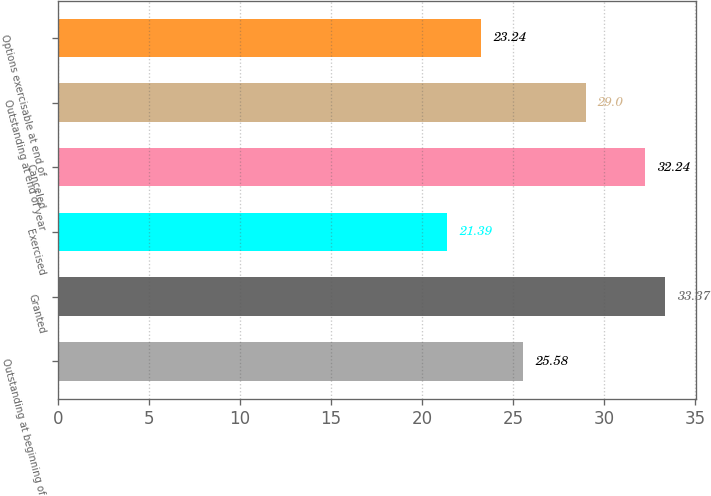Convert chart to OTSL. <chart><loc_0><loc_0><loc_500><loc_500><bar_chart><fcel>Outstanding at beginning of<fcel>Granted<fcel>Exercised<fcel>Canceled<fcel>Outstanding at end of year<fcel>Options exercisable at end of<nl><fcel>25.58<fcel>33.37<fcel>21.39<fcel>32.24<fcel>29<fcel>23.24<nl></chart> 